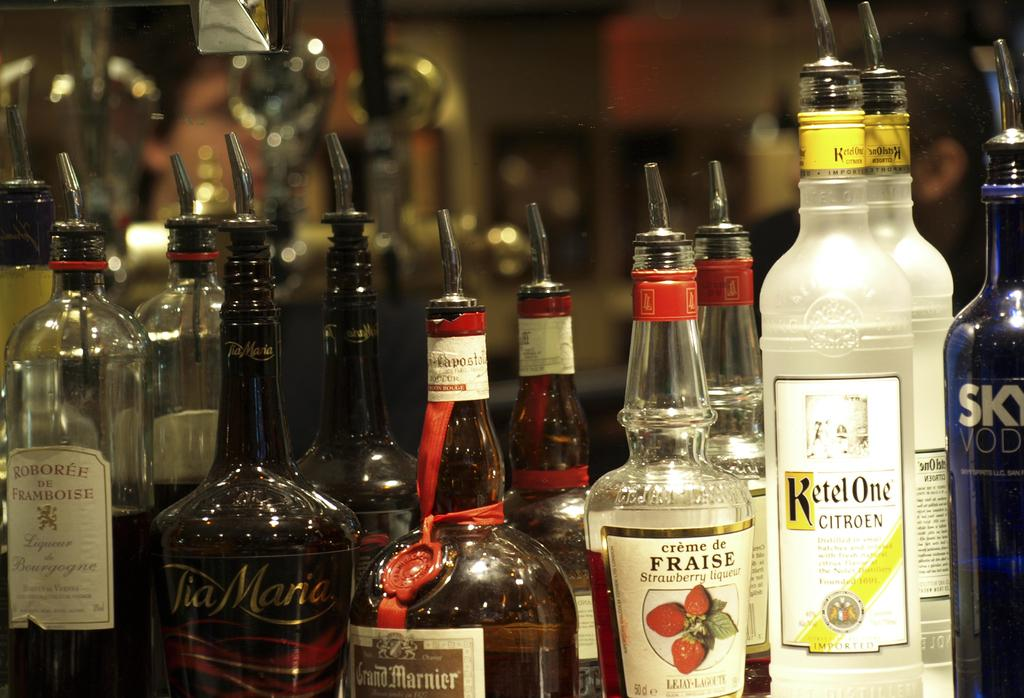<image>
Summarize the visual content of the image. An assortment of liquor bottles including Ketel One and Grand Mariner. 